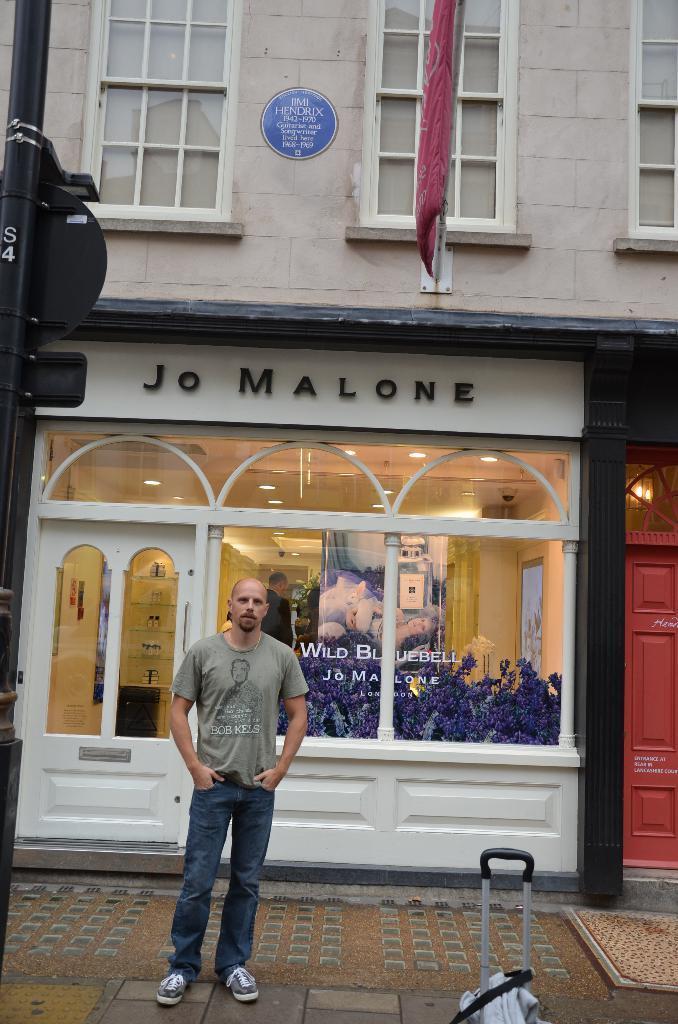In one or two sentences, can you explain what this image depicts? A man is standing, he wore t-shirt, trouser. Behind him there is a glass wall and this is the building. 